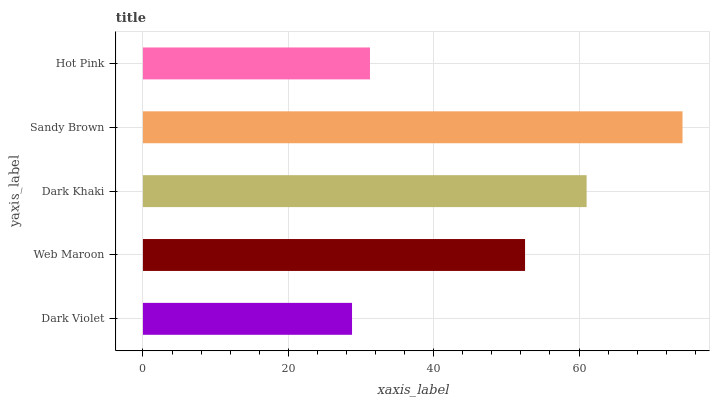Is Dark Violet the minimum?
Answer yes or no. Yes. Is Sandy Brown the maximum?
Answer yes or no. Yes. Is Web Maroon the minimum?
Answer yes or no. No. Is Web Maroon the maximum?
Answer yes or no. No. Is Web Maroon greater than Dark Violet?
Answer yes or no. Yes. Is Dark Violet less than Web Maroon?
Answer yes or no. Yes. Is Dark Violet greater than Web Maroon?
Answer yes or no. No. Is Web Maroon less than Dark Violet?
Answer yes or no. No. Is Web Maroon the high median?
Answer yes or no. Yes. Is Web Maroon the low median?
Answer yes or no. Yes. Is Dark Khaki the high median?
Answer yes or no. No. Is Dark Khaki the low median?
Answer yes or no. No. 